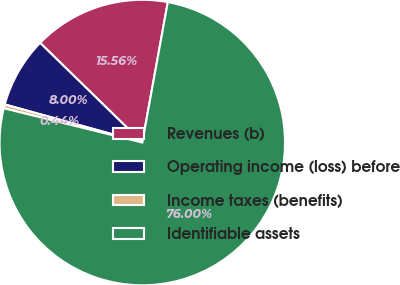<chart> <loc_0><loc_0><loc_500><loc_500><pie_chart><fcel>Revenues (b)<fcel>Operating income (loss) before<fcel>Income taxes (benefits)<fcel>Identifiable assets<nl><fcel>15.56%<fcel>8.0%<fcel>0.44%<fcel>76.0%<nl></chart> 